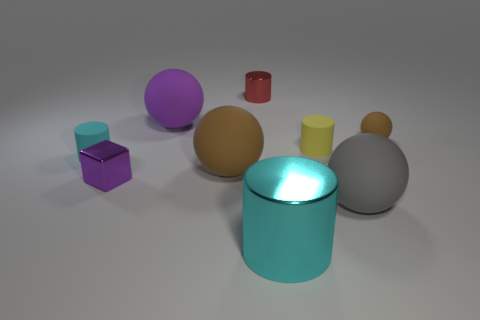Is there any other thing that has the same shape as the tiny purple metal thing?
Ensure brevity in your answer.  No. Are the big cylinder and the tiny red cylinder made of the same material?
Ensure brevity in your answer.  Yes. What is the size of the cylinder that is both on the left side of the large shiny object and to the right of the cyan rubber cylinder?
Offer a terse response. Small. How many cylinders have the same size as the purple rubber sphere?
Offer a terse response. 1. There is a brown matte sphere that is in front of the yellow object that is on the right side of the purple matte ball; what is its size?
Give a very brief answer. Large. There is a object behind the purple sphere; is it the same shape as the rubber object left of the large purple ball?
Provide a succinct answer. Yes. What color is the matte sphere that is behind the block and right of the big brown rubber thing?
Offer a very short reply. Brown. Is there a matte thing of the same color as the tiny metallic cube?
Provide a short and direct response. Yes. There is a big ball that is right of the small shiny cylinder; what color is it?
Offer a very short reply. Gray. Are there any tiny cyan matte cylinders that are behind the tiny cylinder right of the large cyan thing?
Provide a succinct answer. No. 